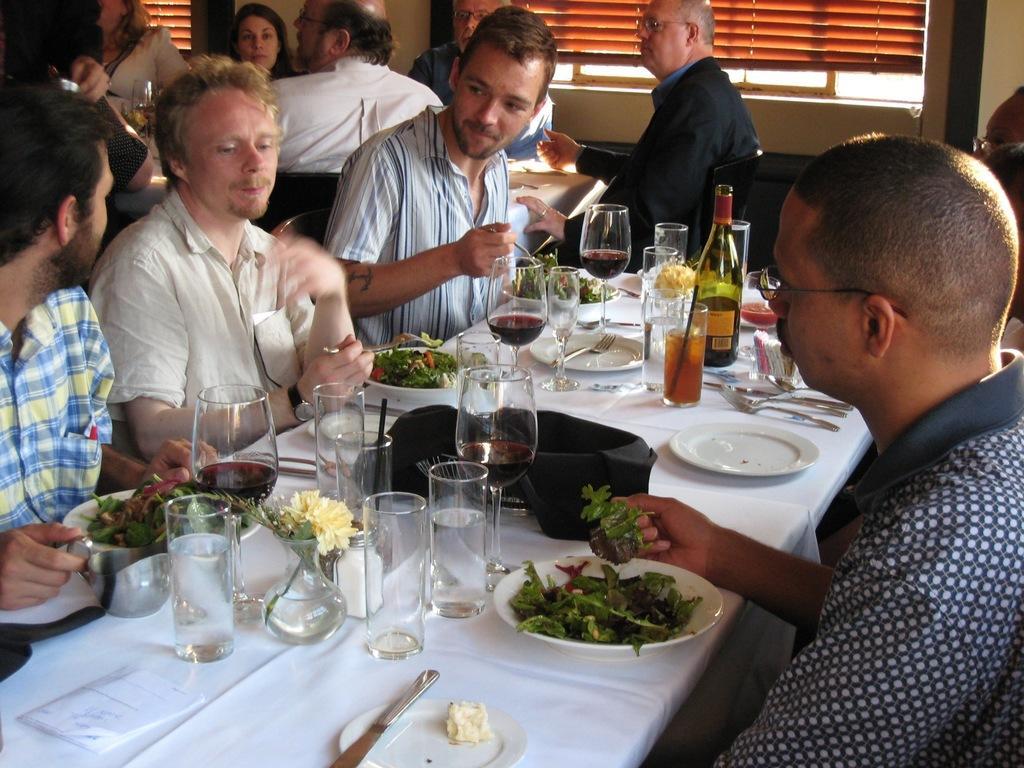Could you give a brief overview of what you see in this image? This picture describes about group of people, they are all seated on the chairs, in front of them we can see a bottle, few glasses, plates, spoons and other things on the table, in the background we can find window blinds. 